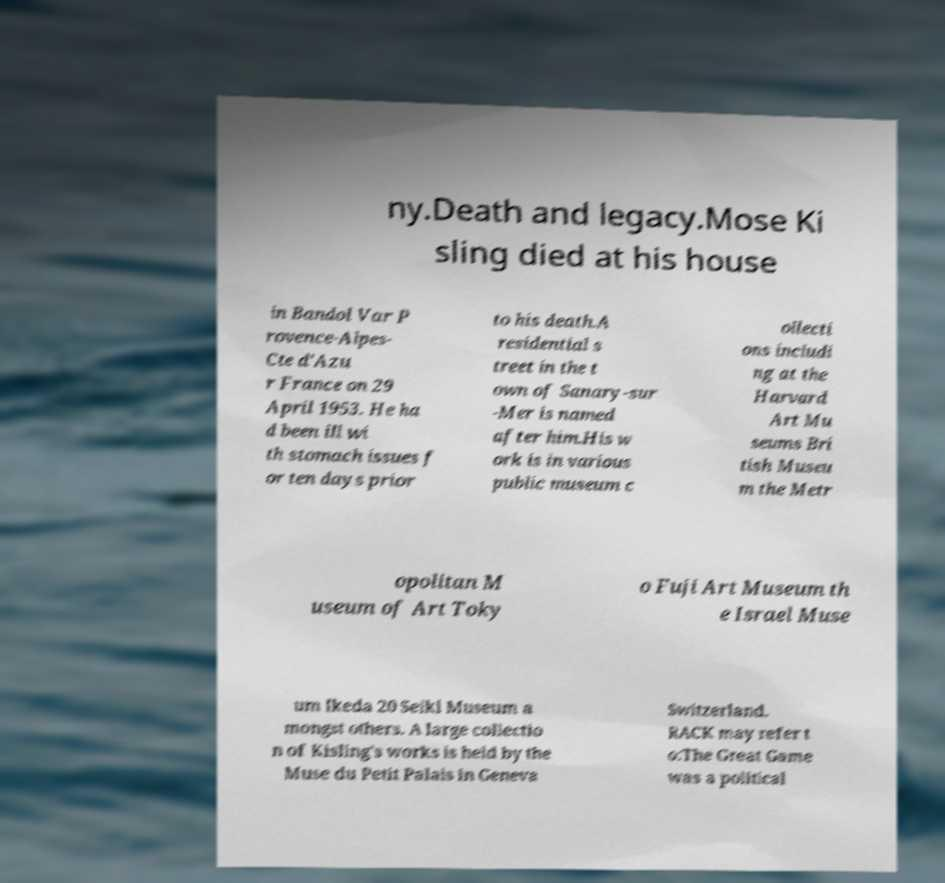Can you accurately transcribe the text from the provided image for me? ny.Death and legacy.Mose Ki sling died at his house in Bandol Var P rovence-Alpes- Cte d'Azu r France on 29 April 1953. He ha d been ill wi th stomach issues f or ten days prior to his death.A residential s treet in the t own of Sanary-sur -Mer is named after him.His w ork is in various public museum c ollecti ons includi ng at the Harvard Art Mu seums Bri tish Museu m the Metr opolitan M useum of Art Toky o Fuji Art Museum th e Israel Muse um Ikeda 20 Seiki Museum a mongst others. A large collectio n of Kisling's works is held by the Muse du Petit Palais in Geneva Switzerland. RACK may refer t o:The Great Game was a political 